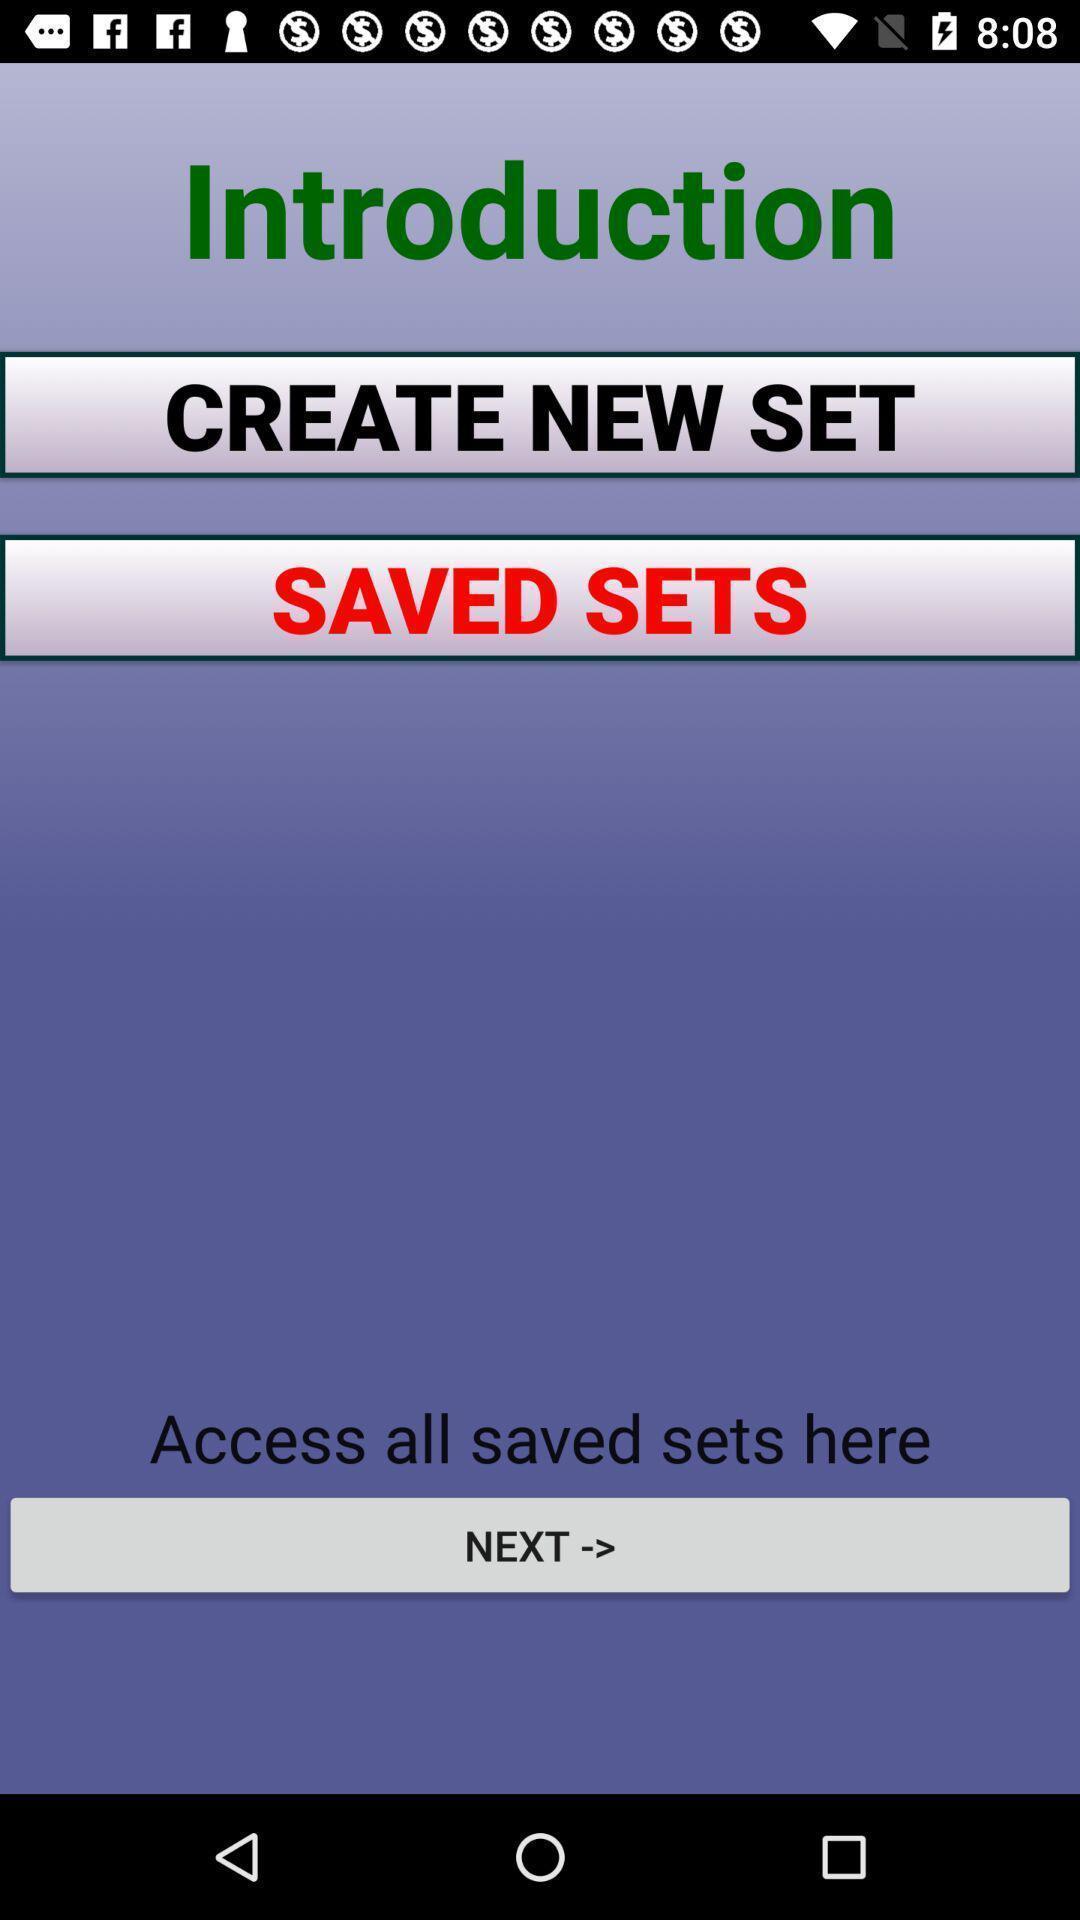Explain what's happening in this screen capture. Welcome page of application with options. 